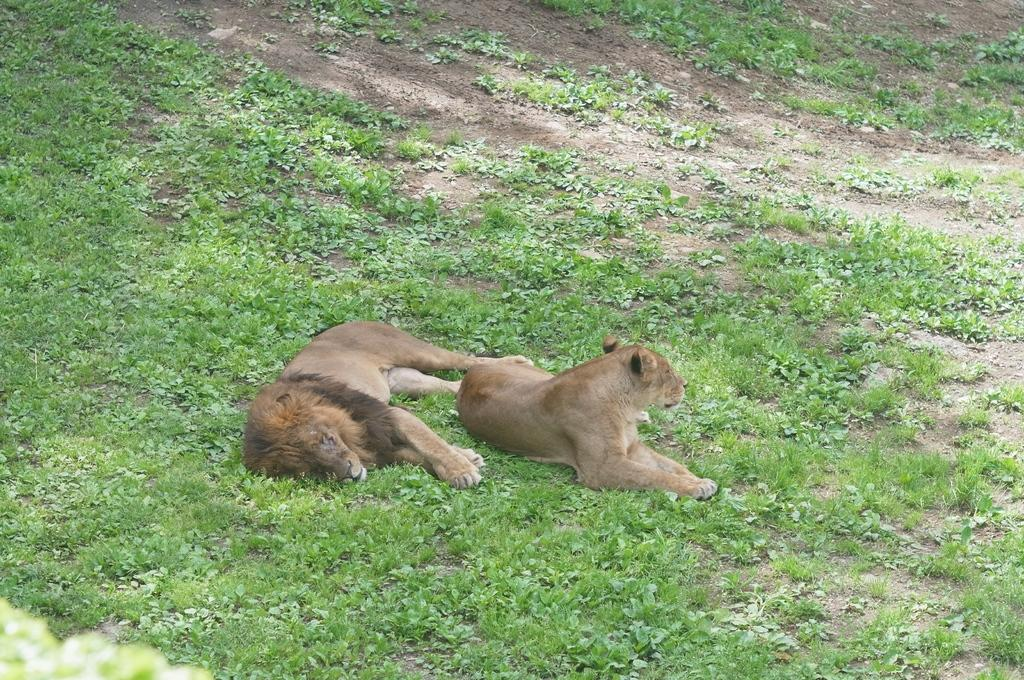How many animals are present in the image? There are two animals in the image. What are the animals doing in the image? The animals are lying on the ground. What type of wilderness can be seen in the background of the image? There is no wilderness visible in the image; it only shows two animals lying on the ground. How many copies of the animals are present in the image? There is only one set of two animals in the image, so there are no copies. 